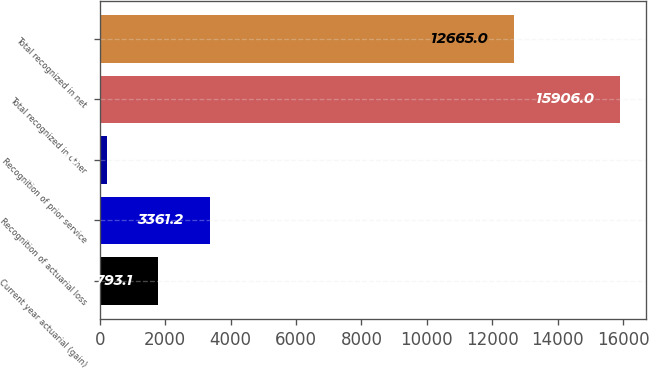<chart> <loc_0><loc_0><loc_500><loc_500><bar_chart><fcel>Current year actuarial (gain)<fcel>Recognition of actuarial loss<fcel>Recognition of prior service<fcel>Total recognized in other<fcel>Total recognized in net<nl><fcel>1793.1<fcel>3361.2<fcel>225<fcel>15906<fcel>12665<nl></chart> 